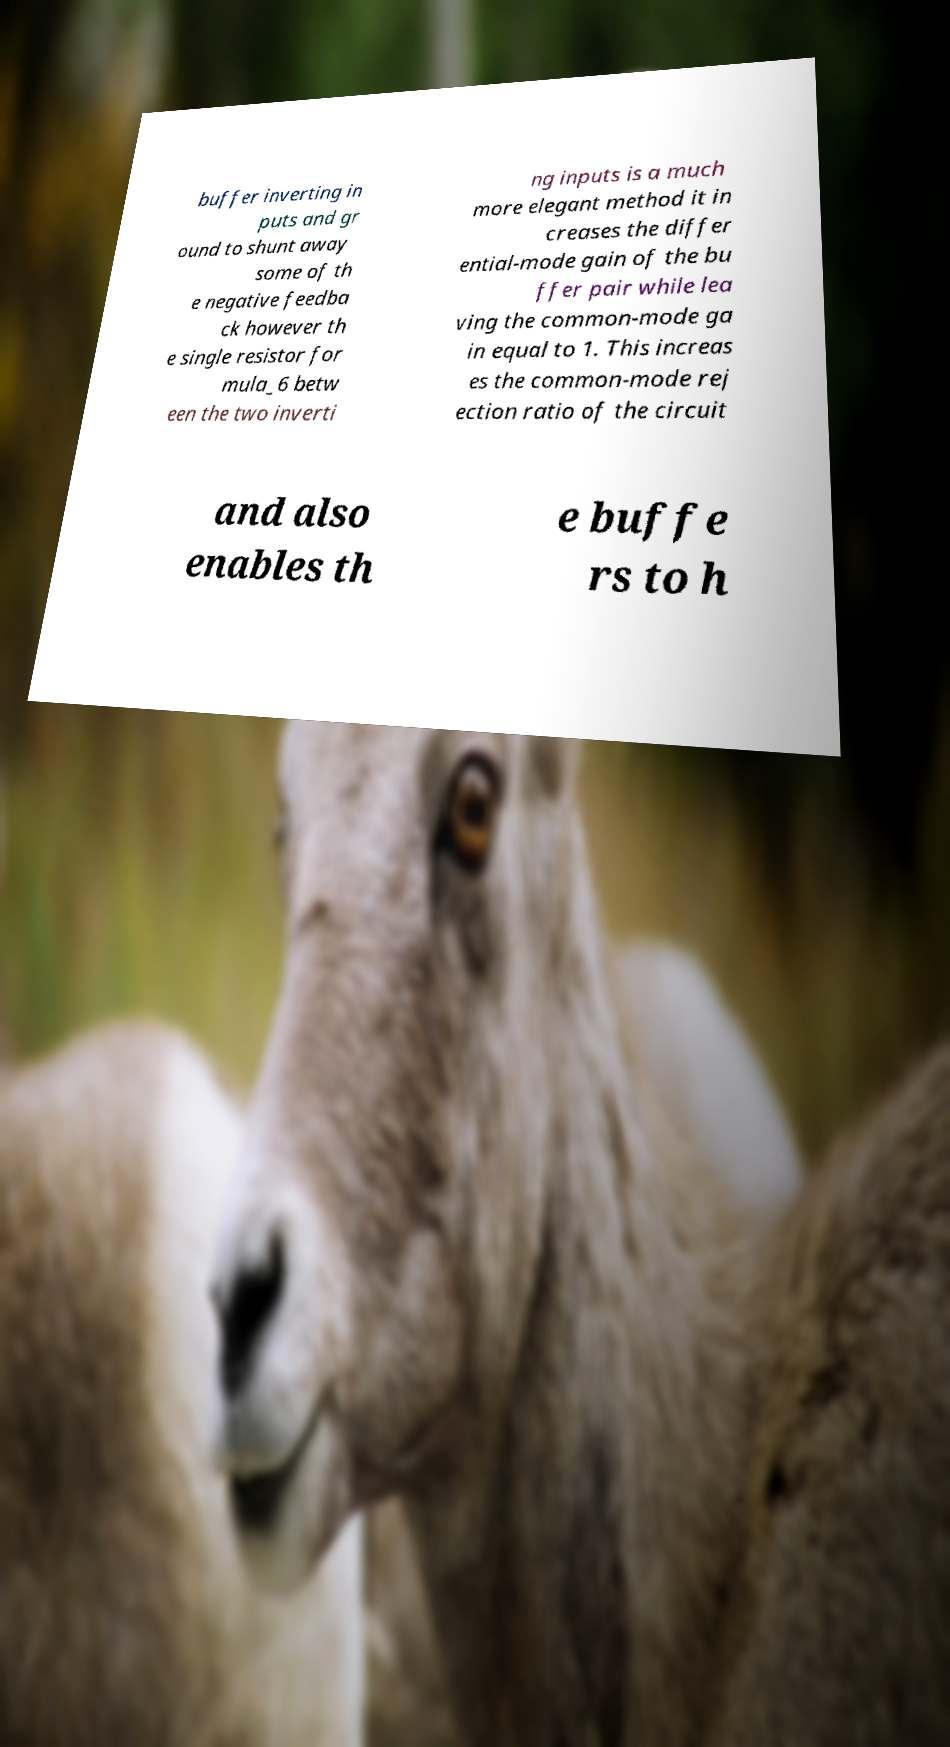Could you assist in decoding the text presented in this image and type it out clearly? buffer inverting in puts and gr ound to shunt away some of th e negative feedba ck however th e single resistor for mula_6 betw een the two inverti ng inputs is a much more elegant method it in creases the differ ential-mode gain of the bu ffer pair while lea ving the common-mode ga in equal to 1. This increas es the common-mode rej ection ratio of the circuit and also enables th e buffe rs to h 